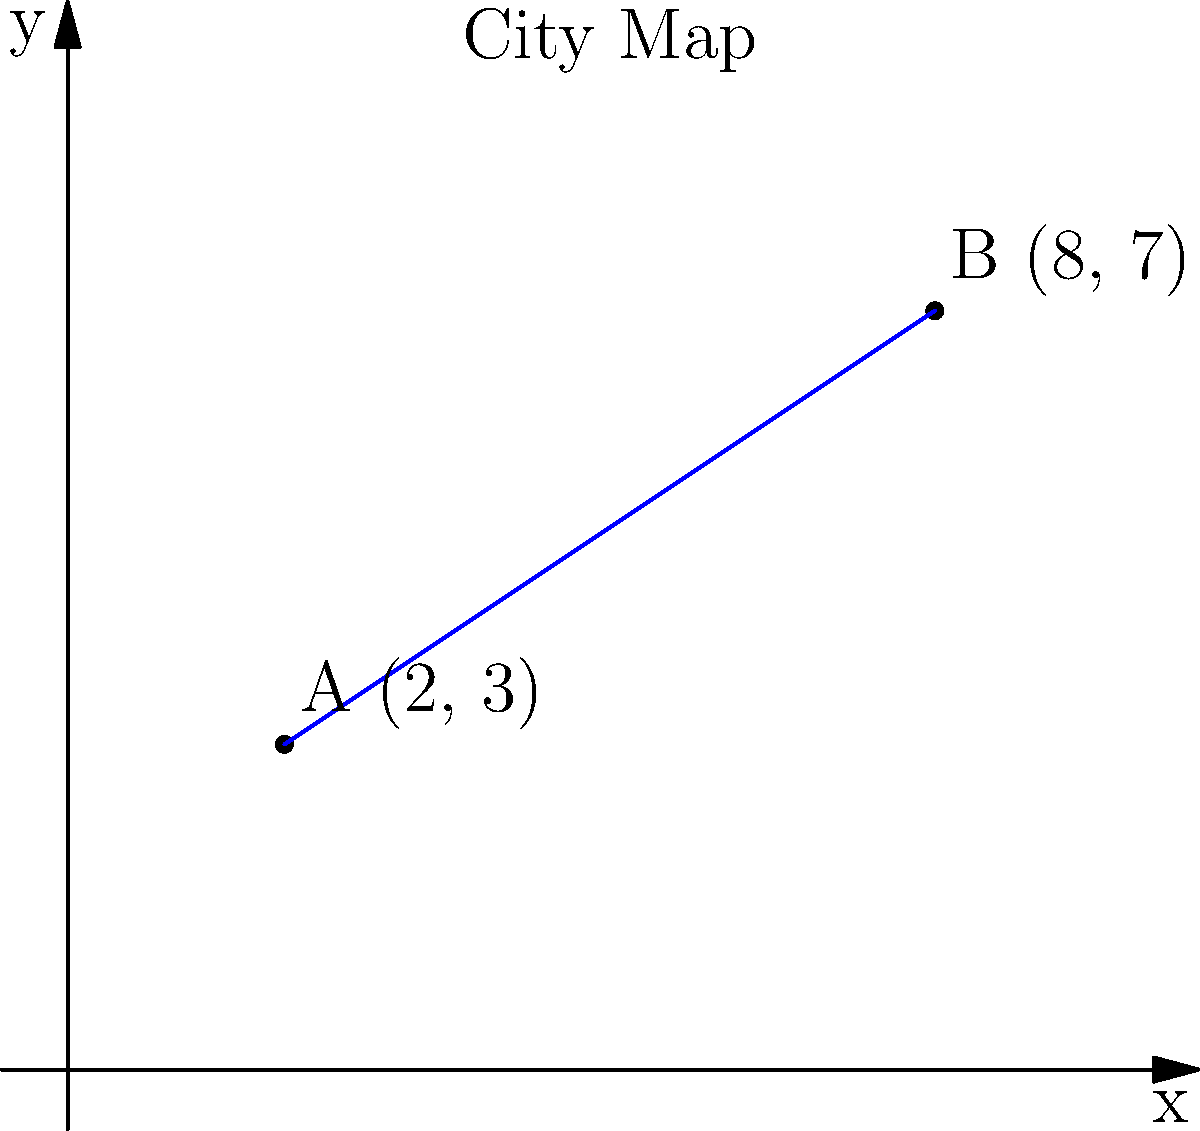On a city map represented by a coordinate plane, two libraries are located at points A(2, 3) and B(8, 7). Using the distance formula, calculate the shortest distance between these two libraries to determine the most efficient route for a book exchange program. Round your answer to the nearest tenth of a unit. To find the distance between two points on a coordinate plane, we use the distance formula:

$$d = \sqrt{(x_2 - x_1)^2 + (y_2 - y_1)^2}$$

Where $(x_1, y_1)$ is the coordinate of the first point and $(x_2, y_2)$ is the coordinate of the second point.

Given:
Point A: $(2, 3)$
Point B: $(8, 7)$

Let's substitute these values into the formula:

$$d = \sqrt{(8 - 2)^2 + (7 - 3)^2}$$

Now, let's solve step-by-step:

1. Calculate the differences:
   $$d = \sqrt{(6)^2 + (4)^2}$$

2. Square the differences:
   $$d = \sqrt{36 + 16}$$

3. Add the squared differences:
   $$d = \sqrt{52}$$

4. Calculate the square root:
   $$d \approx 7.21$$

5. Round to the nearest tenth:
   $$d \approx 7.2$$

Therefore, the shortest distance between the two libraries is approximately 7.2 units on the city map.
Answer: 7.2 units 